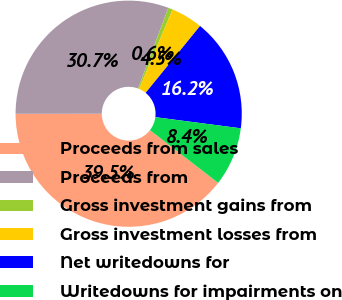Convert chart. <chart><loc_0><loc_0><loc_500><loc_500><pie_chart><fcel>Proceeds from sales<fcel>Proceeds from<fcel>Gross investment gains from<fcel>Gross investment losses from<fcel>Net writedowns for<fcel>Writedowns for impairments on<nl><fcel>39.52%<fcel>30.72%<fcel>0.64%<fcel>4.53%<fcel>16.19%<fcel>8.41%<nl></chart> 